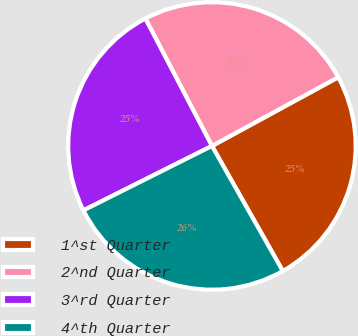<chart> <loc_0><loc_0><loc_500><loc_500><pie_chart><fcel>1^st Quarter<fcel>2^nd Quarter<fcel>3^rd Quarter<fcel>4^th Quarter<nl><fcel>24.73%<fcel>24.73%<fcel>24.73%<fcel>25.81%<nl></chart> 